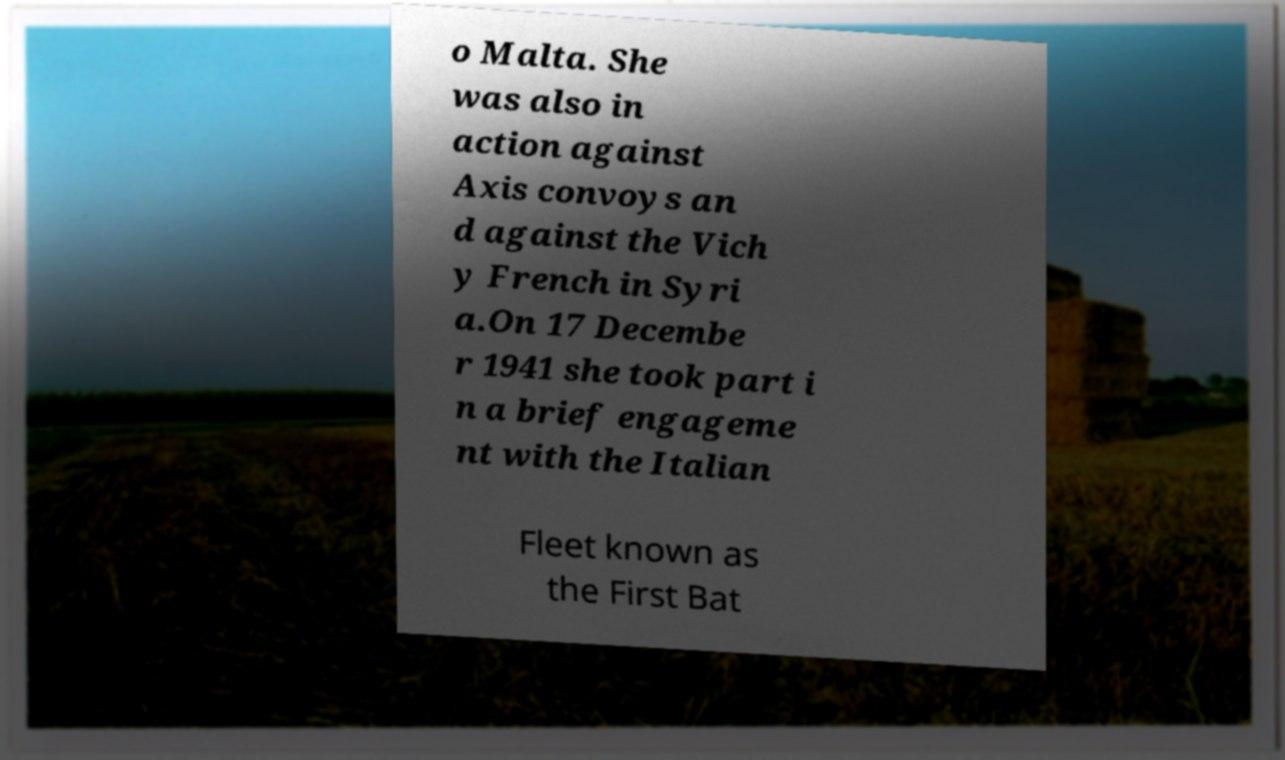For documentation purposes, I need the text within this image transcribed. Could you provide that? o Malta. She was also in action against Axis convoys an d against the Vich y French in Syri a.On 17 Decembe r 1941 she took part i n a brief engageme nt with the Italian Fleet known as the First Bat 